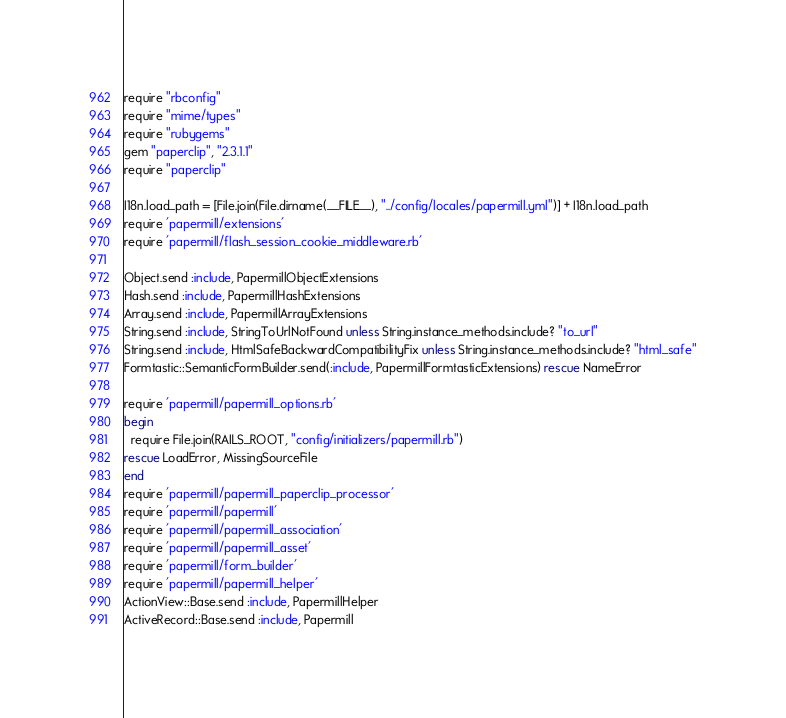<code> <loc_0><loc_0><loc_500><loc_500><_Ruby_>require "rbconfig"
require "mime/types"
require "rubygems"
gem "paperclip", "2.3.1.1"
require "paperclip"

I18n.load_path = [File.join(File.dirname(__FILE__), "../config/locales/papermill.yml")] + I18n.load_path
require 'papermill/extensions'
require 'papermill/flash_session_cookie_middleware.rb'

Object.send :include, PapermillObjectExtensions
Hash.send :include, PapermillHashExtensions
Array.send :include, PapermillArrayExtensions
String.send :include, StringToUrlNotFound unless String.instance_methods.include? "to_url"
String.send :include, HtmlSafeBackwardCompatibilityFix unless String.instance_methods.include? "html_safe"
Formtastic::SemanticFormBuilder.send(:include, PapermillFormtasticExtensions) rescue NameError

require 'papermill/papermill_options.rb'
begin
  require File.join(RAILS_ROOT, "config/initializers/papermill.rb") 
rescue LoadError, MissingSourceFile
end
require 'papermill/papermill_paperclip_processor'
require 'papermill/papermill'
require 'papermill/papermill_association'
require 'papermill/papermill_asset'
require 'papermill/form_builder'
require 'papermill/papermill_helper'
ActionView::Base.send :include, PapermillHelper
ActiveRecord::Base.send :include, Papermill
</code> 